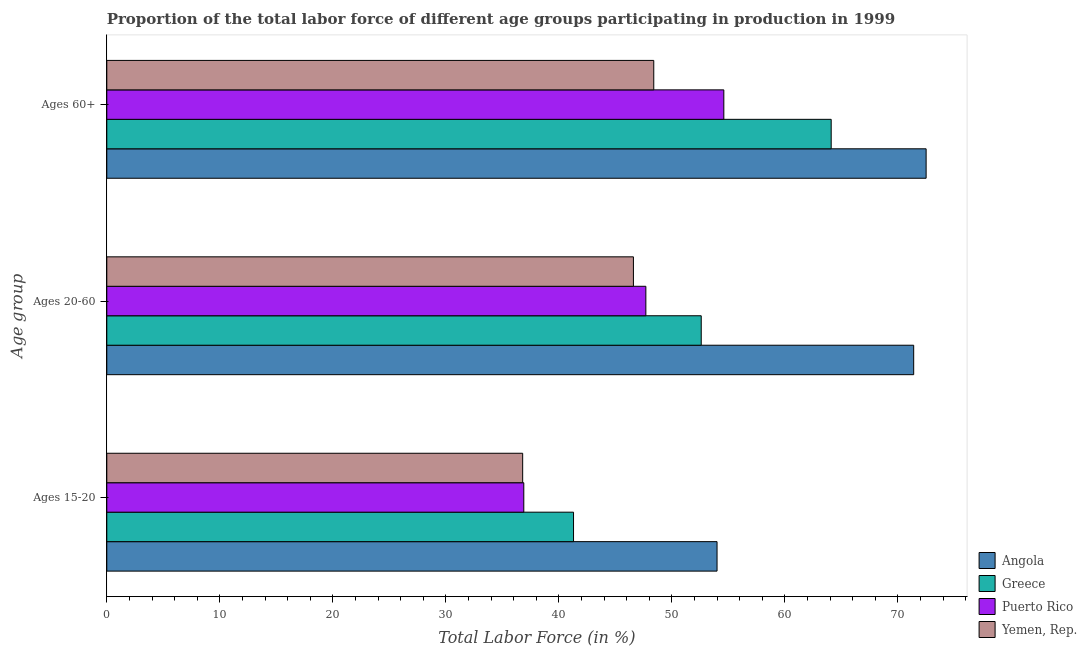How many bars are there on the 2nd tick from the top?
Offer a terse response. 4. How many bars are there on the 3rd tick from the bottom?
Make the answer very short. 4. What is the label of the 3rd group of bars from the top?
Ensure brevity in your answer.  Ages 15-20. What is the percentage of labor force within the age group 15-20 in Puerto Rico?
Ensure brevity in your answer.  36.9. Across all countries, what is the maximum percentage of labor force above age 60?
Your answer should be very brief. 72.5. Across all countries, what is the minimum percentage of labor force above age 60?
Your response must be concise. 48.4. In which country was the percentage of labor force within the age group 15-20 maximum?
Your response must be concise. Angola. In which country was the percentage of labor force within the age group 15-20 minimum?
Provide a short and direct response. Yemen, Rep. What is the total percentage of labor force within the age group 15-20 in the graph?
Give a very brief answer. 169. What is the difference between the percentage of labor force above age 60 in Angola and that in Greece?
Offer a terse response. 8.4. What is the difference between the percentage of labor force above age 60 in Yemen, Rep. and the percentage of labor force within the age group 20-60 in Angola?
Keep it short and to the point. -23. What is the average percentage of labor force within the age group 20-60 per country?
Ensure brevity in your answer.  54.57. What is the difference between the percentage of labor force above age 60 and percentage of labor force within the age group 20-60 in Angola?
Provide a succinct answer. 1.1. In how many countries, is the percentage of labor force within the age group 15-20 greater than 74 %?
Offer a very short reply. 0. What is the ratio of the percentage of labor force within the age group 15-20 in Greece to that in Yemen, Rep.?
Provide a short and direct response. 1.12. Is the percentage of labor force within the age group 15-20 in Puerto Rico less than that in Angola?
Give a very brief answer. Yes. Is the difference between the percentage of labor force within the age group 15-20 in Angola and Greece greater than the difference between the percentage of labor force above age 60 in Angola and Greece?
Make the answer very short. Yes. What is the difference between the highest and the second highest percentage of labor force above age 60?
Your answer should be compact. 8.4. What is the difference between the highest and the lowest percentage of labor force above age 60?
Ensure brevity in your answer.  24.1. What does the 4th bar from the top in Ages 60+ represents?
Ensure brevity in your answer.  Angola. What does the 2nd bar from the bottom in Ages 15-20 represents?
Make the answer very short. Greece. Is it the case that in every country, the sum of the percentage of labor force within the age group 15-20 and percentage of labor force within the age group 20-60 is greater than the percentage of labor force above age 60?
Your response must be concise. Yes. How many bars are there?
Make the answer very short. 12. How many countries are there in the graph?
Keep it short and to the point. 4. What is the difference between two consecutive major ticks on the X-axis?
Offer a very short reply. 10. Does the graph contain any zero values?
Keep it short and to the point. No. Does the graph contain grids?
Your answer should be compact. No. Where does the legend appear in the graph?
Provide a short and direct response. Bottom right. How are the legend labels stacked?
Give a very brief answer. Vertical. What is the title of the graph?
Your response must be concise. Proportion of the total labor force of different age groups participating in production in 1999. Does "Palau" appear as one of the legend labels in the graph?
Your answer should be very brief. No. What is the label or title of the Y-axis?
Provide a short and direct response. Age group. What is the Total Labor Force (in %) in Greece in Ages 15-20?
Keep it short and to the point. 41.3. What is the Total Labor Force (in %) in Puerto Rico in Ages 15-20?
Provide a succinct answer. 36.9. What is the Total Labor Force (in %) in Yemen, Rep. in Ages 15-20?
Give a very brief answer. 36.8. What is the Total Labor Force (in %) in Angola in Ages 20-60?
Provide a succinct answer. 71.4. What is the Total Labor Force (in %) in Greece in Ages 20-60?
Provide a succinct answer. 52.6. What is the Total Labor Force (in %) in Puerto Rico in Ages 20-60?
Offer a very short reply. 47.7. What is the Total Labor Force (in %) in Yemen, Rep. in Ages 20-60?
Offer a very short reply. 46.6. What is the Total Labor Force (in %) of Angola in Ages 60+?
Offer a terse response. 72.5. What is the Total Labor Force (in %) of Greece in Ages 60+?
Provide a short and direct response. 64.1. What is the Total Labor Force (in %) of Puerto Rico in Ages 60+?
Give a very brief answer. 54.6. What is the Total Labor Force (in %) of Yemen, Rep. in Ages 60+?
Provide a short and direct response. 48.4. Across all Age group, what is the maximum Total Labor Force (in %) of Angola?
Your answer should be very brief. 72.5. Across all Age group, what is the maximum Total Labor Force (in %) in Greece?
Offer a terse response. 64.1. Across all Age group, what is the maximum Total Labor Force (in %) in Puerto Rico?
Your answer should be very brief. 54.6. Across all Age group, what is the maximum Total Labor Force (in %) in Yemen, Rep.?
Provide a succinct answer. 48.4. Across all Age group, what is the minimum Total Labor Force (in %) of Angola?
Your response must be concise. 54. Across all Age group, what is the minimum Total Labor Force (in %) of Greece?
Provide a short and direct response. 41.3. Across all Age group, what is the minimum Total Labor Force (in %) in Puerto Rico?
Offer a very short reply. 36.9. Across all Age group, what is the minimum Total Labor Force (in %) of Yemen, Rep.?
Your answer should be compact. 36.8. What is the total Total Labor Force (in %) of Angola in the graph?
Your answer should be very brief. 197.9. What is the total Total Labor Force (in %) of Greece in the graph?
Ensure brevity in your answer.  158. What is the total Total Labor Force (in %) of Puerto Rico in the graph?
Keep it short and to the point. 139.2. What is the total Total Labor Force (in %) of Yemen, Rep. in the graph?
Your answer should be compact. 131.8. What is the difference between the Total Labor Force (in %) in Angola in Ages 15-20 and that in Ages 20-60?
Provide a succinct answer. -17.4. What is the difference between the Total Labor Force (in %) in Greece in Ages 15-20 and that in Ages 20-60?
Provide a succinct answer. -11.3. What is the difference between the Total Labor Force (in %) of Puerto Rico in Ages 15-20 and that in Ages 20-60?
Make the answer very short. -10.8. What is the difference between the Total Labor Force (in %) in Angola in Ages 15-20 and that in Ages 60+?
Provide a succinct answer. -18.5. What is the difference between the Total Labor Force (in %) of Greece in Ages 15-20 and that in Ages 60+?
Give a very brief answer. -22.8. What is the difference between the Total Labor Force (in %) of Puerto Rico in Ages 15-20 and that in Ages 60+?
Your answer should be very brief. -17.7. What is the difference between the Total Labor Force (in %) of Yemen, Rep. in Ages 15-20 and that in Ages 60+?
Ensure brevity in your answer.  -11.6. What is the difference between the Total Labor Force (in %) of Greece in Ages 20-60 and that in Ages 60+?
Provide a succinct answer. -11.5. What is the difference between the Total Labor Force (in %) in Angola in Ages 15-20 and the Total Labor Force (in %) in Greece in Ages 20-60?
Your answer should be very brief. 1.4. What is the difference between the Total Labor Force (in %) in Angola in Ages 15-20 and the Total Labor Force (in %) in Yemen, Rep. in Ages 20-60?
Give a very brief answer. 7.4. What is the difference between the Total Labor Force (in %) of Greece in Ages 15-20 and the Total Labor Force (in %) of Yemen, Rep. in Ages 60+?
Keep it short and to the point. -7.1. What is the difference between the Total Labor Force (in %) of Puerto Rico in Ages 15-20 and the Total Labor Force (in %) of Yemen, Rep. in Ages 60+?
Keep it short and to the point. -11.5. What is the difference between the Total Labor Force (in %) of Angola in Ages 20-60 and the Total Labor Force (in %) of Greece in Ages 60+?
Offer a very short reply. 7.3. What is the difference between the Total Labor Force (in %) in Angola in Ages 20-60 and the Total Labor Force (in %) in Puerto Rico in Ages 60+?
Your response must be concise. 16.8. What is the difference between the Total Labor Force (in %) of Angola in Ages 20-60 and the Total Labor Force (in %) of Yemen, Rep. in Ages 60+?
Your answer should be compact. 23. What is the difference between the Total Labor Force (in %) of Greece in Ages 20-60 and the Total Labor Force (in %) of Puerto Rico in Ages 60+?
Offer a very short reply. -2. What is the difference between the Total Labor Force (in %) of Greece in Ages 20-60 and the Total Labor Force (in %) of Yemen, Rep. in Ages 60+?
Keep it short and to the point. 4.2. What is the difference between the Total Labor Force (in %) in Puerto Rico in Ages 20-60 and the Total Labor Force (in %) in Yemen, Rep. in Ages 60+?
Your response must be concise. -0.7. What is the average Total Labor Force (in %) of Angola per Age group?
Ensure brevity in your answer.  65.97. What is the average Total Labor Force (in %) of Greece per Age group?
Ensure brevity in your answer.  52.67. What is the average Total Labor Force (in %) in Puerto Rico per Age group?
Keep it short and to the point. 46.4. What is the average Total Labor Force (in %) of Yemen, Rep. per Age group?
Your answer should be compact. 43.93. What is the difference between the Total Labor Force (in %) of Angola and Total Labor Force (in %) of Greece in Ages 15-20?
Provide a short and direct response. 12.7. What is the difference between the Total Labor Force (in %) in Angola and Total Labor Force (in %) in Yemen, Rep. in Ages 15-20?
Offer a very short reply. 17.2. What is the difference between the Total Labor Force (in %) of Greece and Total Labor Force (in %) of Puerto Rico in Ages 15-20?
Offer a terse response. 4.4. What is the difference between the Total Labor Force (in %) in Puerto Rico and Total Labor Force (in %) in Yemen, Rep. in Ages 15-20?
Your answer should be very brief. 0.1. What is the difference between the Total Labor Force (in %) in Angola and Total Labor Force (in %) in Puerto Rico in Ages 20-60?
Ensure brevity in your answer.  23.7. What is the difference between the Total Labor Force (in %) in Angola and Total Labor Force (in %) in Yemen, Rep. in Ages 20-60?
Ensure brevity in your answer.  24.8. What is the difference between the Total Labor Force (in %) of Greece and Total Labor Force (in %) of Puerto Rico in Ages 20-60?
Offer a terse response. 4.9. What is the difference between the Total Labor Force (in %) of Puerto Rico and Total Labor Force (in %) of Yemen, Rep. in Ages 20-60?
Provide a short and direct response. 1.1. What is the difference between the Total Labor Force (in %) in Angola and Total Labor Force (in %) in Puerto Rico in Ages 60+?
Offer a very short reply. 17.9. What is the difference between the Total Labor Force (in %) of Angola and Total Labor Force (in %) of Yemen, Rep. in Ages 60+?
Give a very brief answer. 24.1. What is the difference between the Total Labor Force (in %) of Greece and Total Labor Force (in %) of Yemen, Rep. in Ages 60+?
Keep it short and to the point. 15.7. What is the ratio of the Total Labor Force (in %) of Angola in Ages 15-20 to that in Ages 20-60?
Provide a succinct answer. 0.76. What is the ratio of the Total Labor Force (in %) in Greece in Ages 15-20 to that in Ages 20-60?
Ensure brevity in your answer.  0.79. What is the ratio of the Total Labor Force (in %) of Puerto Rico in Ages 15-20 to that in Ages 20-60?
Offer a terse response. 0.77. What is the ratio of the Total Labor Force (in %) in Yemen, Rep. in Ages 15-20 to that in Ages 20-60?
Keep it short and to the point. 0.79. What is the ratio of the Total Labor Force (in %) of Angola in Ages 15-20 to that in Ages 60+?
Provide a succinct answer. 0.74. What is the ratio of the Total Labor Force (in %) of Greece in Ages 15-20 to that in Ages 60+?
Offer a very short reply. 0.64. What is the ratio of the Total Labor Force (in %) of Puerto Rico in Ages 15-20 to that in Ages 60+?
Give a very brief answer. 0.68. What is the ratio of the Total Labor Force (in %) of Yemen, Rep. in Ages 15-20 to that in Ages 60+?
Your response must be concise. 0.76. What is the ratio of the Total Labor Force (in %) in Angola in Ages 20-60 to that in Ages 60+?
Your response must be concise. 0.98. What is the ratio of the Total Labor Force (in %) in Greece in Ages 20-60 to that in Ages 60+?
Ensure brevity in your answer.  0.82. What is the ratio of the Total Labor Force (in %) of Puerto Rico in Ages 20-60 to that in Ages 60+?
Offer a very short reply. 0.87. What is the ratio of the Total Labor Force (in %) in Yemen, Rep. in Ages 20-60 to that in Ages 60+?
Make the answer very short. 0.96. What is the difference between the highest and the second highest Total Labor Force (in %) in Angola?
Your answer should be compact. 1.1. What is the difference between the highest and the second highest Total Labor Force (in %) of Puerto Rico?
Ensure brevity in your answer.  6.9. What is the difference between the highest and the lowest Total Labor Force (in %) in Greece?
Your response must be concise. 22.8. What is the difference between the highest and the lowest Total Labor Force (in %) of Yemen, Rep.?
Give a very brief answer. 11.6. 